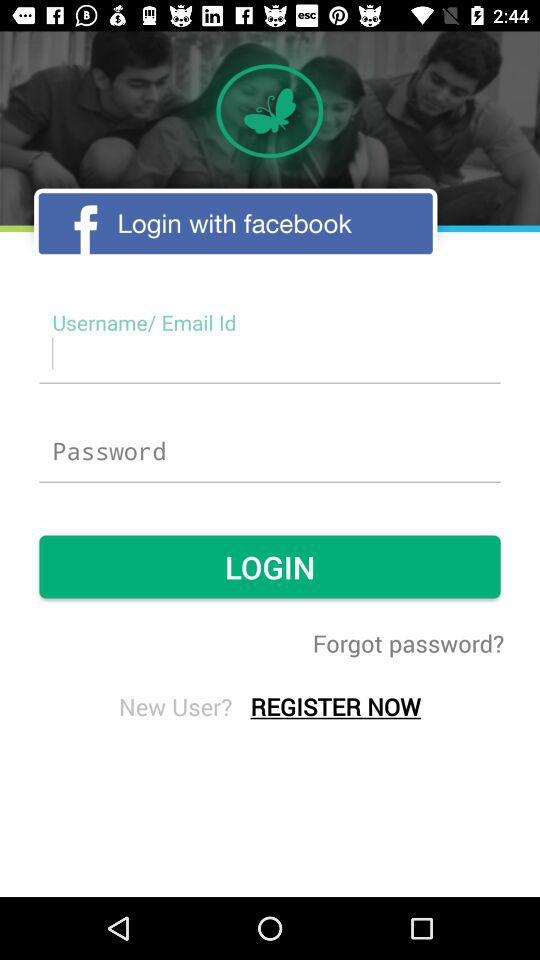What account can I use to log in? You can use "facebook" account to log in. 